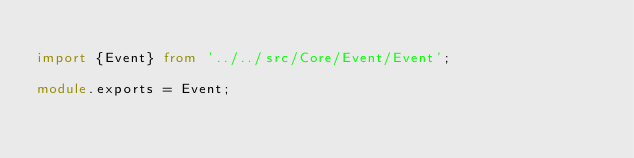Convert code to text. <code><loc_0><loc_0><loc_500><loc_500><_TypeScript_>
import {Event} from '../../src/Core/Event/Event';

module.exports = Event;</code> 